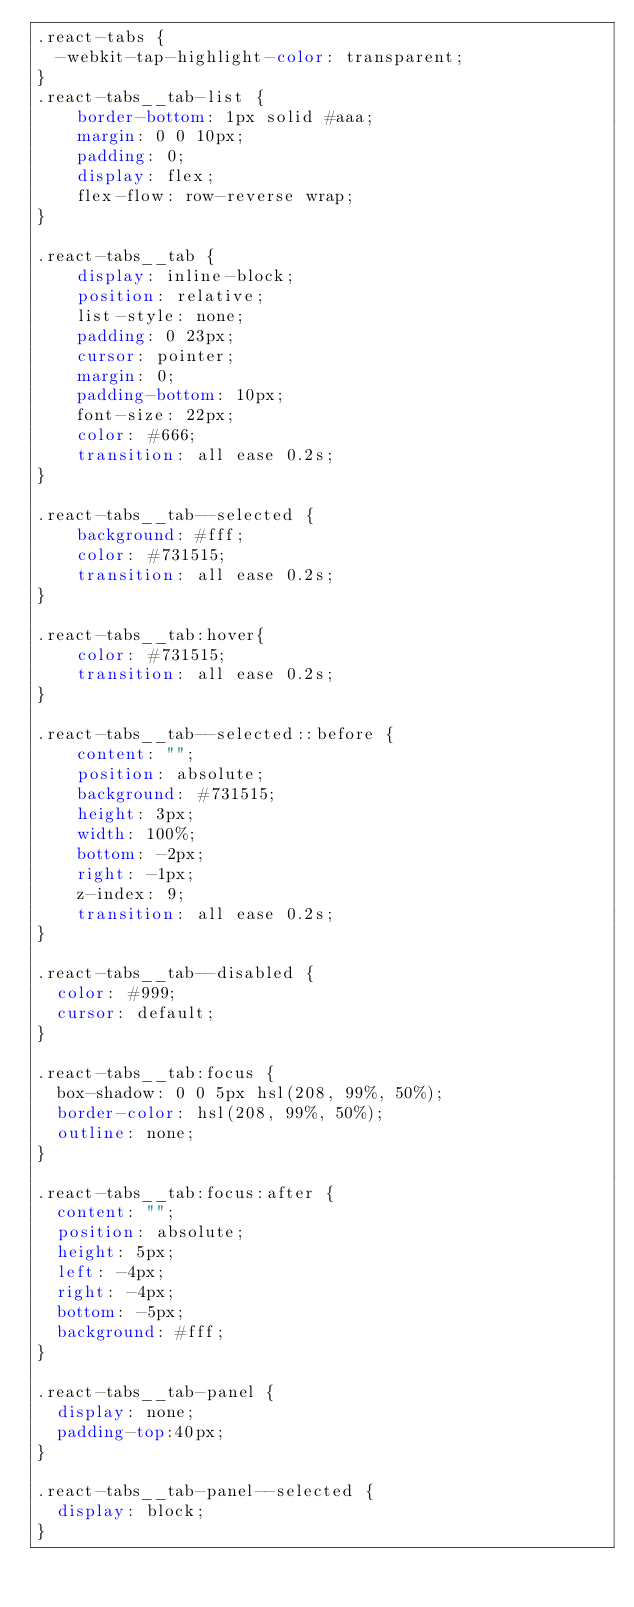Convert code to text. <code><loc_0><loc_0><loc_500><loc_500><_CSS_>.react-tabs {
  -webkit-tap-highlight-color: transparent;
}
.react-tabs__tab-list {
    border-bottom: 1px solid #aaa;
    margin: 0 0 10px;
    padding: 0;
    display: flex;
    flex-flow: row-reverse wrap;
}

.react-tabs__tab {
    display: inline-block;
    position: relative;
    list-style: none;
    padding: 0 23px;
    cursor: pointer;
    margin: 0;
    padding-bottom: 10px;
    font-size: 22px;
    color: #666;
    transition: all ease 0.2s;
}

.react-tabs__tab--selected {
    background: #fff;
    color: #731515;
    transition: all ease 0.2s;
}

.react-tabs__tab:hover{
    color: #731515;
    transition: all ease 0.2s;
}

.react-tabs__tab--selected::before {
    content: "";
    position: absolute;
    background: #731515;
    height: 3px;
    width: 100%;
    bottom: -2px;
    right: -1px;
    z-index: 9;
    transition: all ease 0.2s;
}

.react-tabs__tab--disabled {
  color: #999;
  cursor: default;
}

.react-tabs__tab:focus {
  box-shadow: 0 0 5px hsl(208, 99%, 50%);
  border-color: hsl(208, 99%, 50%);
  outline: none;
}

.react-tabs__tab:focus:after {
  content: "";
  position: absolute;
  height: 5px;
  left: -4px;
  right: -4px;
  bottom: -5px;
  background: #fff;
}

.react-tabs__tab-panel {
  display: none;
  padding-top:40px;
}

.react-tabs__tab-panel--selected {
  display: block;
}
</code> 